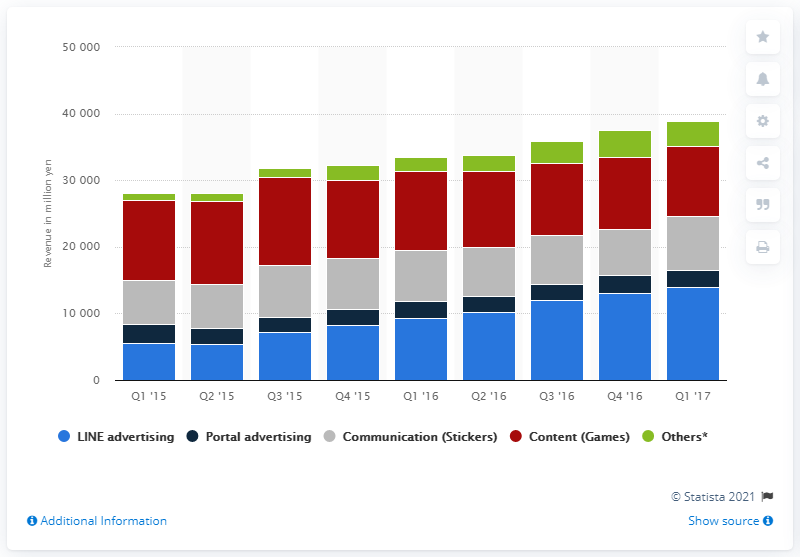Outline some significant characteristics in this image. In the first quarter of 2017, the chat app generated a total of 8,067 stickers in sales. 